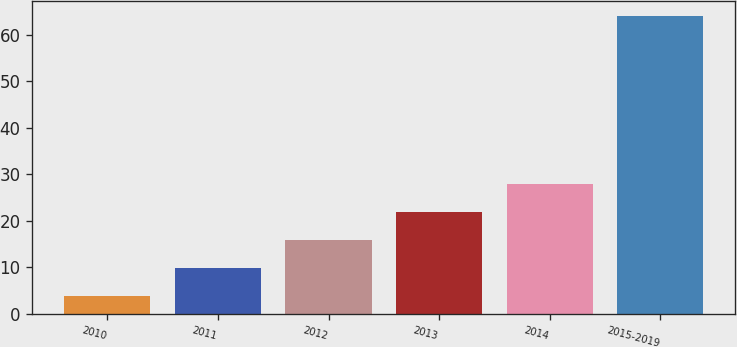Convert chart to OTSL. <chart><loc_0><loc_0><loc_500><loc_500><bar_chart><fcel>2010<fcel>2011<fcel>2012<fcel>2013<fcel>2014<fcel>2015-2019<nl><fcel>3.7<fcel>9.73<fcel>15.76<fcel>21.79<fcel>27.82<fcel>64<nl></chart> 